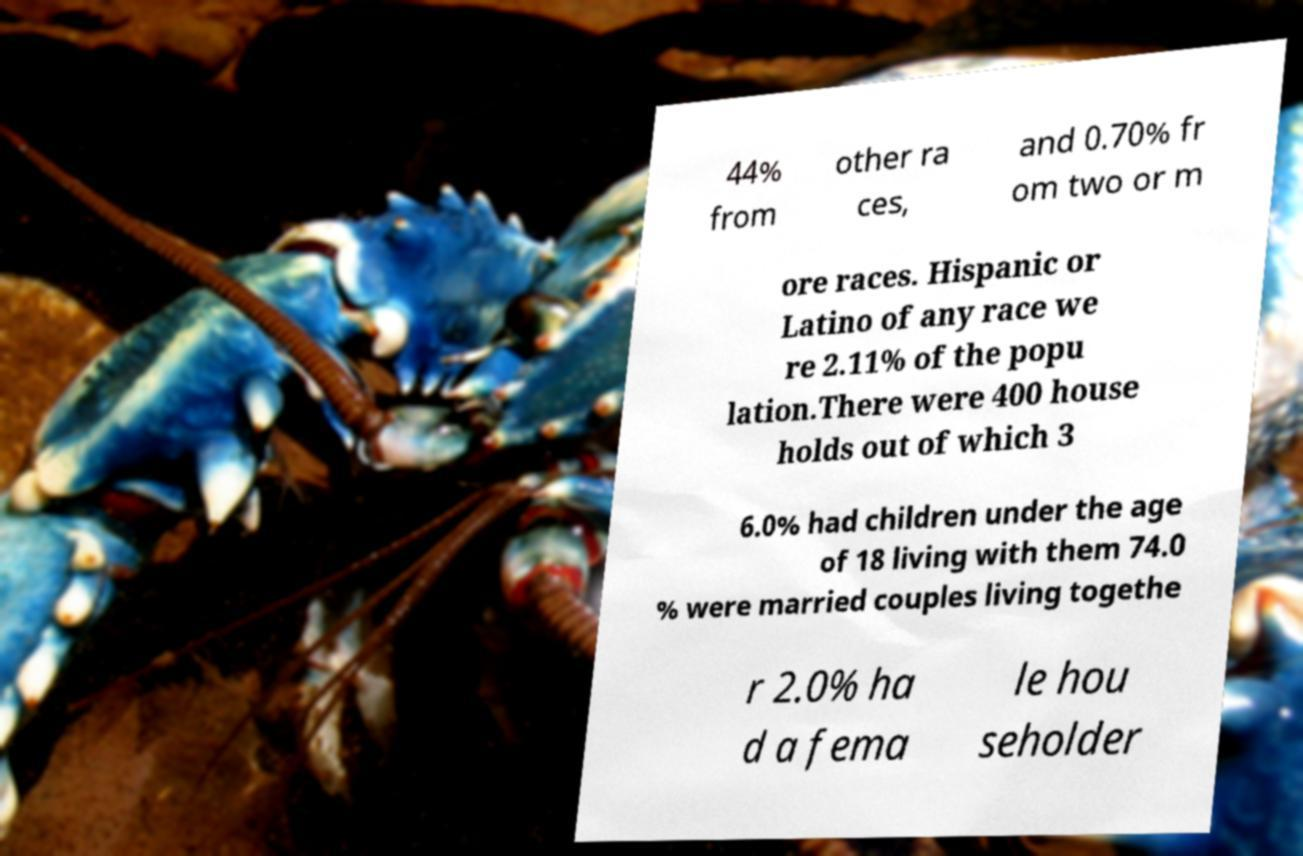Please read and relay the text visible in this image. What does it say? 44% from other ra ces, and 0.70% fr om two or m ore races. Hispanic or Latino of any race we re 2.11% of the popu lation.There were 400 house holds out of which 3 6.0% had children under the age of 18 living with them 74.0 % were married couples living togethe r 2.0% ha d a fema le hou seholder 